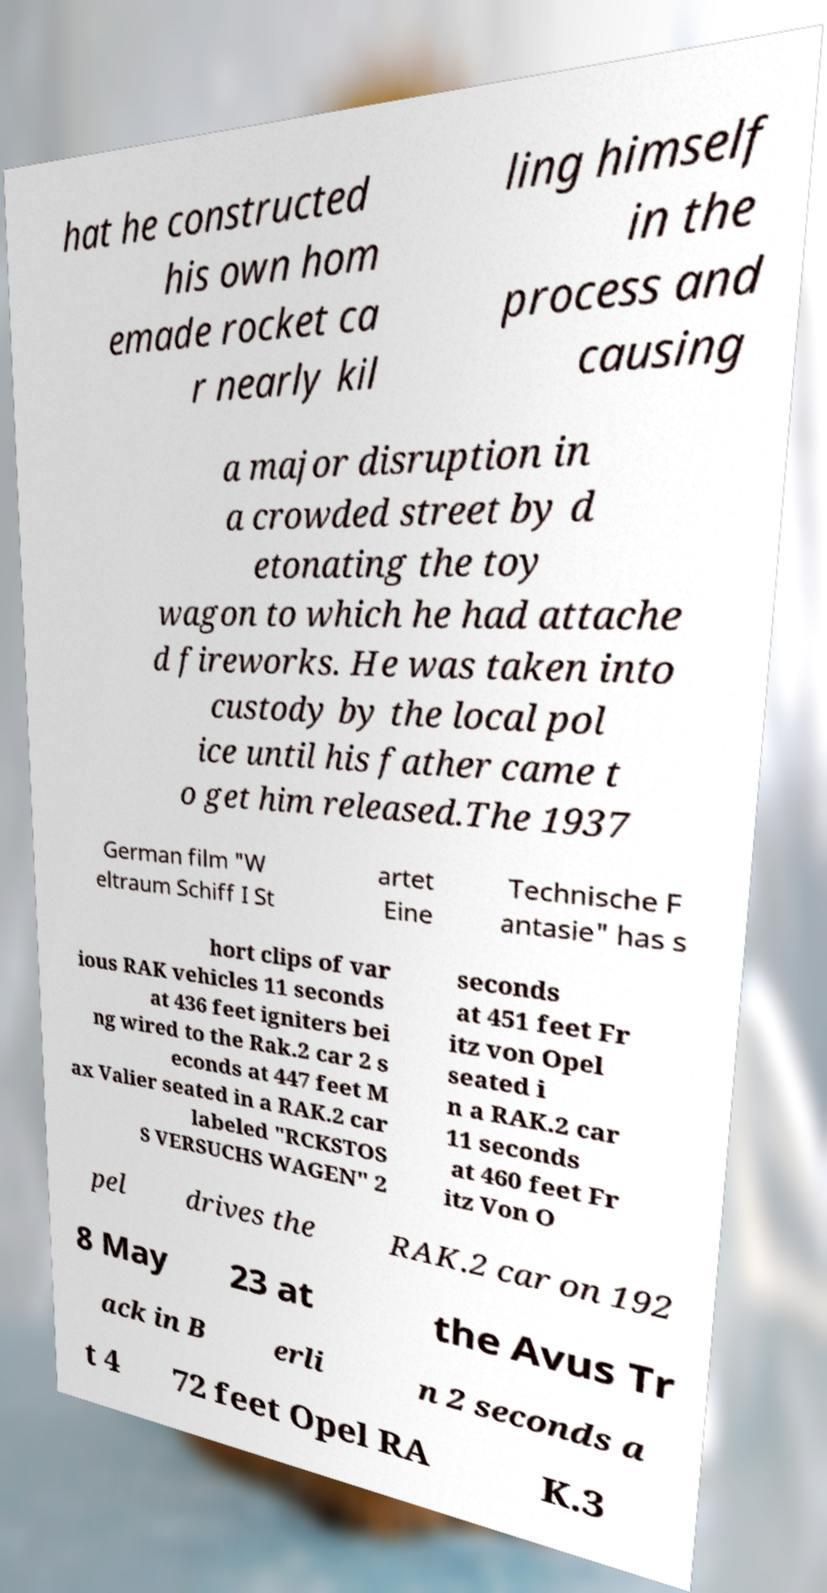Can you read and provide the text displayed in the image?This photo seems to have some interesting text. Can you extract and type it out for me? hat he constructed his own hom emade rocket ca r nearly kil ling himself in the process and causing a major disruption in a crowded street by d etonating the toy wagon to which he had attache d fireworks. He was taken into custody by the local pol ice until his father came t o get him released.The 1937 German film "W eltraum Schiff I St artet Eine Technische F antasie" has s hort clips of var ious RAK vehicles 11 seconds at 436 feet igniters bei ng wired to the Rak.2 car 2 s econds at 447 feet M ax Valier seated in a RAK.2 car labeled "RCKSTOS S VERSUCHS WAGEN" 2 seconds at 451 feet Fr itz von Opel seated i n a RAK.2 car 11 seconds at 460 feet Fr itz Von O pel drives the RAK.2 car on 192 8 May 23 at the Avus Tr ack in B erli n 2 seconds a t 4 72 feet Opel RA K.3 